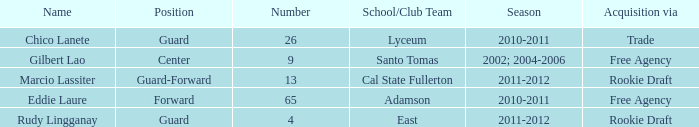What season had an acquisition of free agency, and was higher than 9? 2010-2011. 